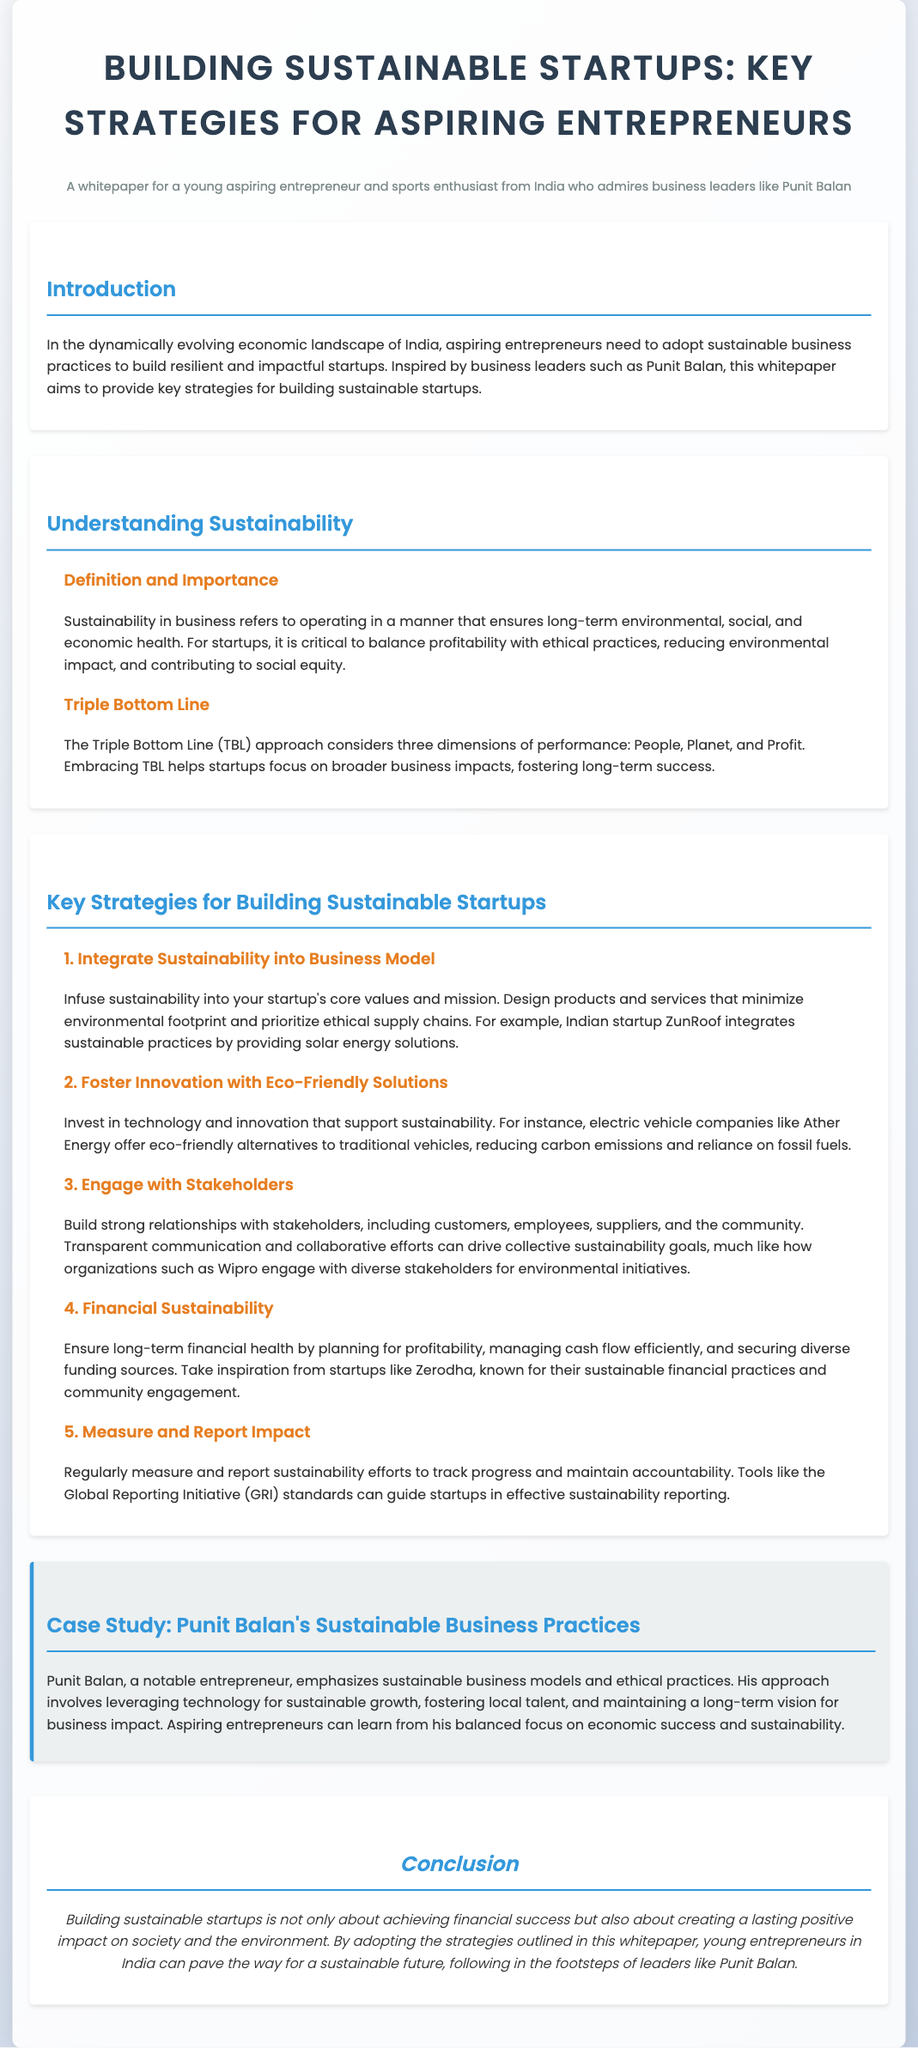What is the purpose of this whitepaper? The purpose of the whitepaper is to provide key strategies for building sustainable startups for aspiring entrepreneurs in India.
Answer: To provide key strategies for building sustainable startups What does TBL stand for? TBL in the context of sustainability refers to the Triple Bottom Line, which considers the performance dimensions of People, Planet, and Profit.
Answer: Triple Bottom Line Which Indian startup provides solar energy solutions? The document mentions ZunRoof as the Indian startup that integrates sustainable practices by providing solar energy solutions.
Answer: ZunRoof What is one example of a company offering eco-friendly alternatives? Ather Energy is given as an example of a company that offers eco-friendly alternatives to traditional vehicles.
Answer: Ather Energy Who is highlighted in the case study for sustainable business practices? Punit Balan is highlighted in the case study for emphasizing sustainable business models and ethical practices.
Answer: Punit Balan What should startups measure and report regularly? Startups should regularly measure and report their sustainability efforts to track progress and maintain accountability.
Answer: Sustainability efforts What does the conclusion emphasize about building sustainable startups? The conclusion emphasizes that building sustainable startups is about creating a lasting positive impact on society and the environment.
Answer: Creating a lasting positive impact How many key strategies for building sustainable startups are listed? There are five key strategies listed for building sustainable startups in the document.
Answer: Five What initiative can guide startups in effective sustainability reporting? The Global Reporting Initiative (GRI) standards can guide startups in effective sustainability reporting.
Answer: Global Reporting Initiative (GRI) standards 